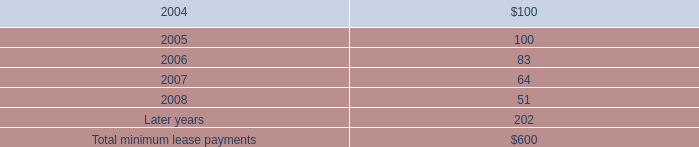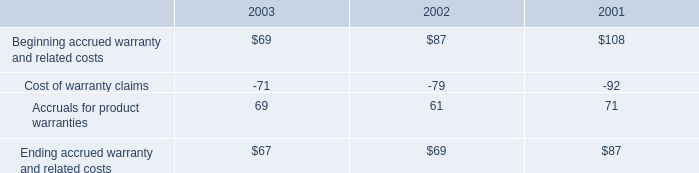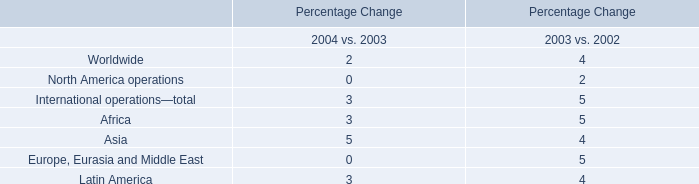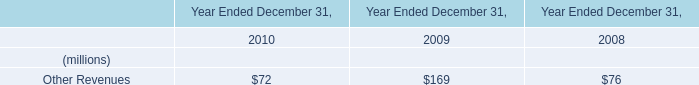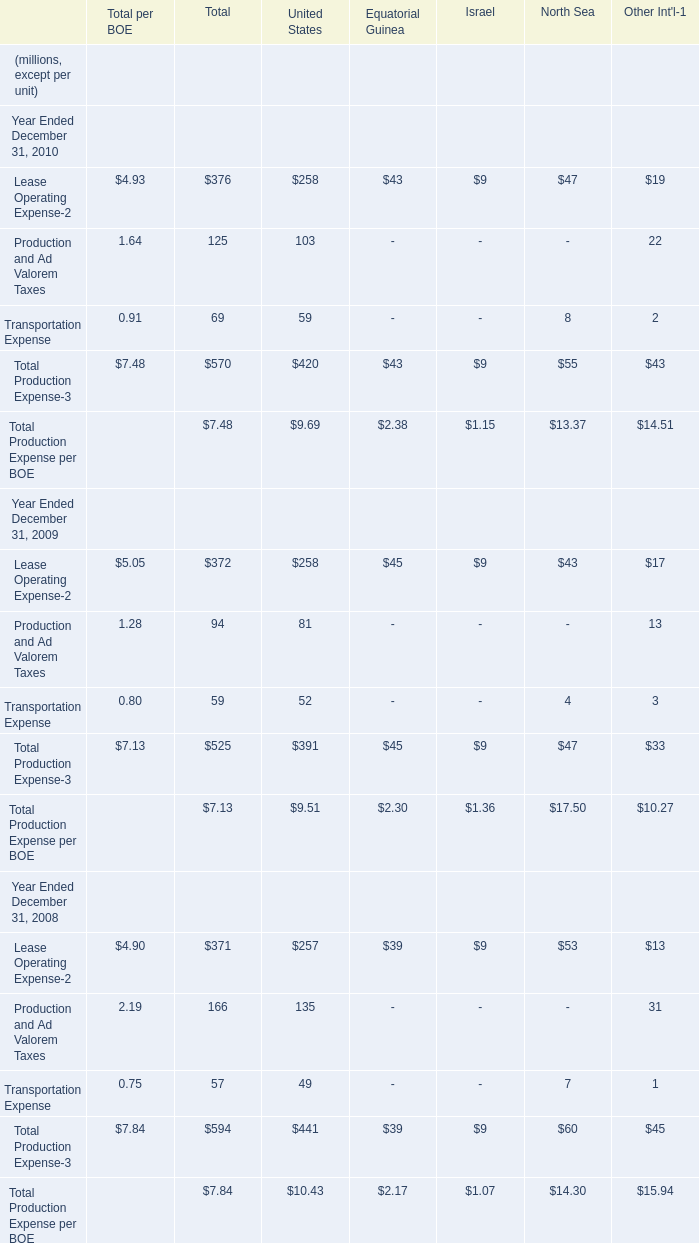Which year has the greatest proportion of Lease Operating Expense-2 ? 
Answer: 2009. 